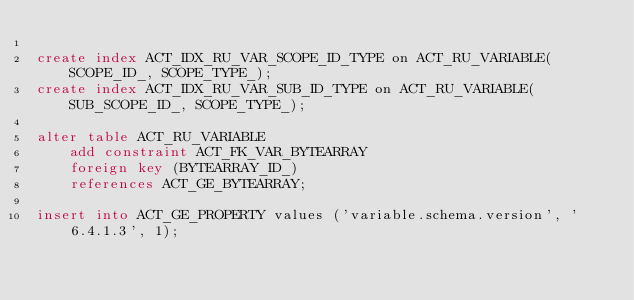<code> <loc_0><loc_0><loc_500><loc_500><_SQL_>
create index ACT_IDX_RU_VAR_SCOPE_ID_TYPE on ACT_RU_VARIABLE(SCOPE_ID_, SCOPE_TYPE_);
create index ACT_IDX_RU_VAR_SUB_ID_TYPE on ACT_RU_VARIABLE(SUB_SCOPE_ID_, SCOPE_TYPE_);

alter table ACT_RU_VARIABLE
    add constraint ACT_FK_VAR_BYTEARRAY
    foreign key (BYTEARRAY_ID_)
    references ACT_GE_BYTEARRAY;

insert into ACT_GE_PROPERTY values ('variable.schema.version', '6.4.1.3', 1);</code> 